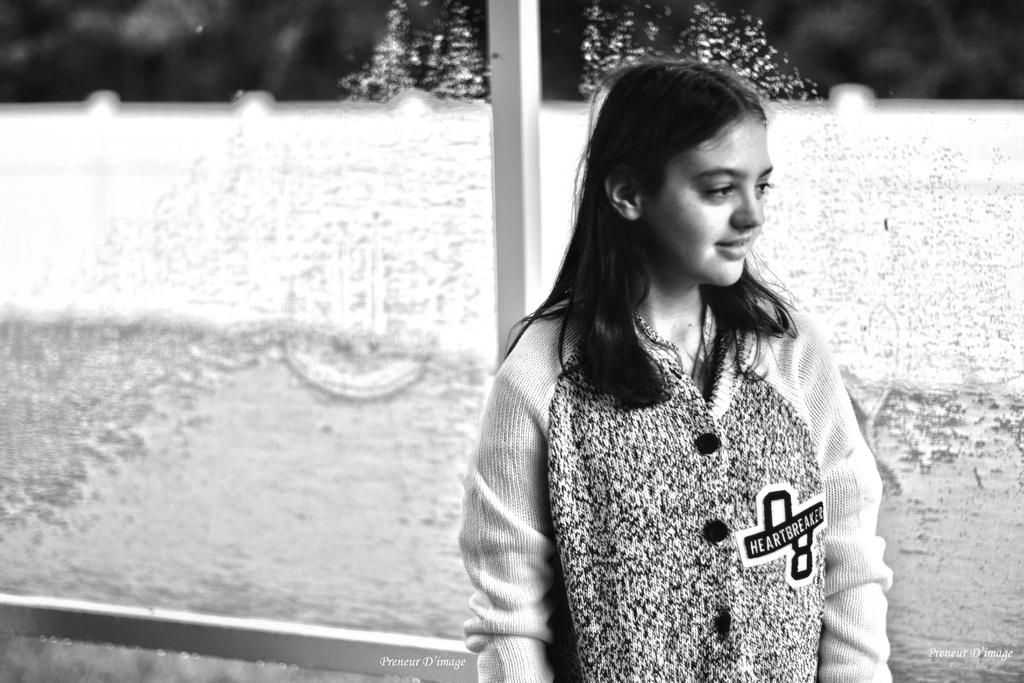What is the color scheme of the image? The image is black and white. Can you describe the main subject in the image? There is a girl in the image. Is the girl in the image holding a wound? There is no mention of a wound in the image, and the girl is not holding anything related to a wound. 